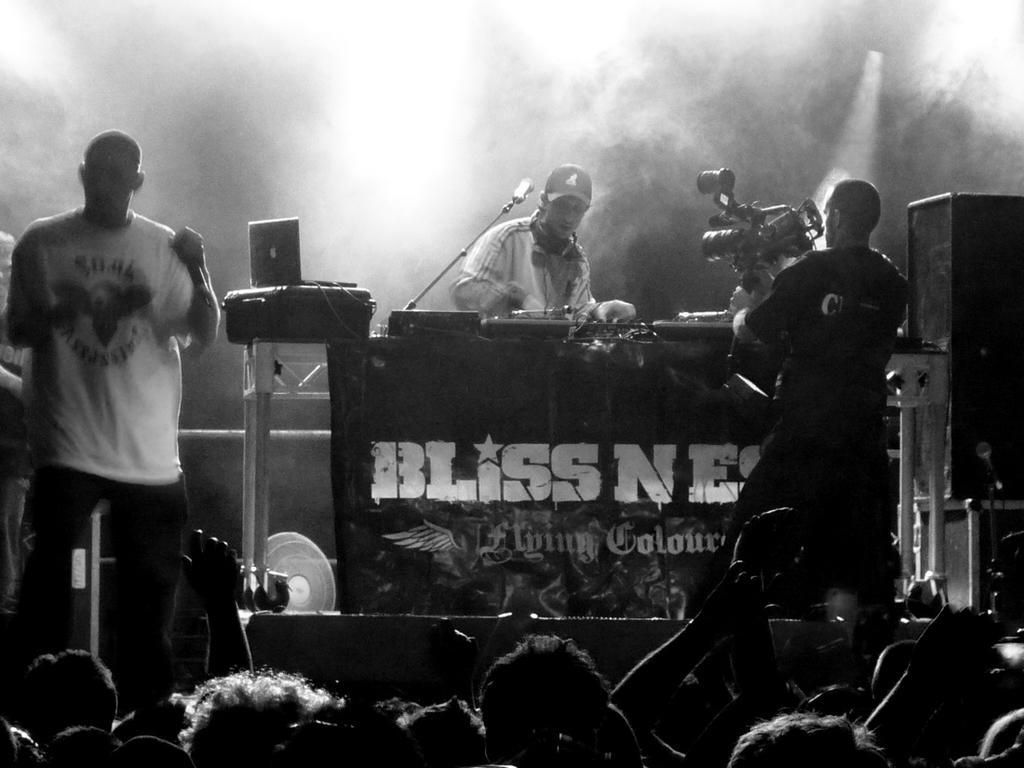In one or two sentences, can you explain what this image depicts? In this black and white picture there is a person behind the table having few objects on it. A person is holding a camera in his hand. Left side there is a person standing on the stage. Bottom of the image there are few persons. Right side there are few objects. 